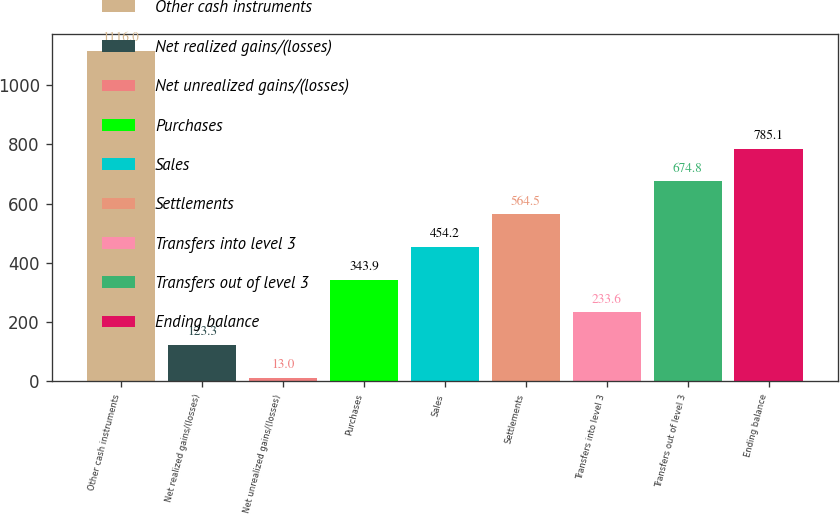<chart> <loc_0><loc_0><loc_500><loc_500><bar_chart><fcel>Other cash instruments<fcel>Net realized gains/(losses)<fcel>Net unrealized gains/(losses)<fcel>Purchases<fcel>Sales<fcel>Settlements<fcel>Transfers into level 3<fcel>Transfers out of level 3<fcel>Ending balance<nl><fcel>1116<fcel>123.3<fcel>13<fcel>343.9<fcel>454.2<fcel>564.5<fcel>233.6<fcel>674.8<fcel>785.1<nl></chart> 